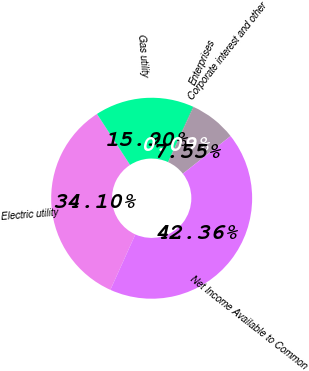Convert chart. <chart><loc_0><loc_0><loc_500><loc_500><pie_chart><fcel>Electric utility<fcel>Gas utility<fcel>Enterprises<fcel>Corporate interest and other<fcel>Net Income Available to Common<nl><fcel>34.1%<fcel>15.9%<fcel>0.09%<fcel>7.55%<fcel>42.36%<nl></chart> 